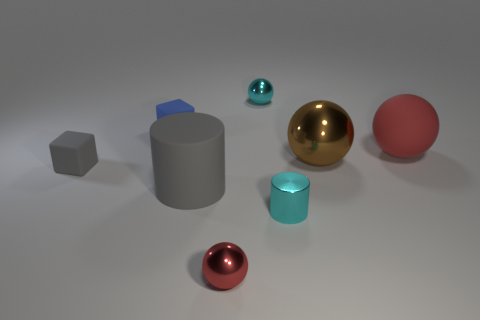Subtract 1 balls. How many balls are left? 3 Subtract all green spheres. Subtract all gray cylinders. How many spheres are left? 4 Add 2 red objects. How many objects exist? 10 Subtract all cubes. How many objects are left? 6 Subtract all small cyan rubber objects. Subtract all large gray cylinders. How many objects are left? 7 Add 1 tiny red shiny balls. How many tiny red shiny balls are left? 2 Add 6 brown shiny cylinders. How many brown shiny cylinders exist? 6 Subtract 0 brown cylinders. How many objects are left? 8 